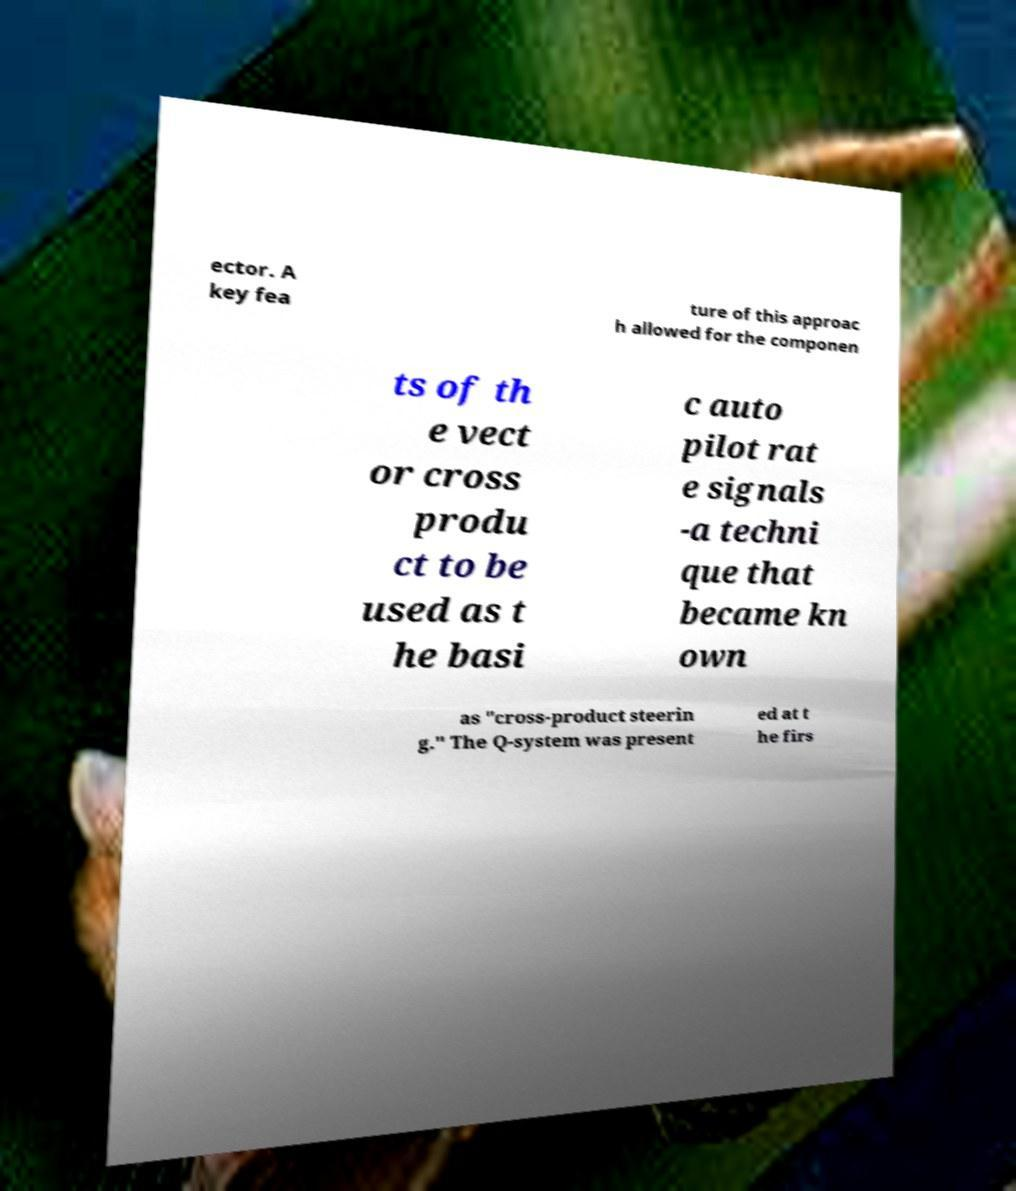Can you read and provide the text displayed in the image?This photo seems to have some interesting text. Can you extract and type it out for me? ector. A key fea ture of this approac h allowed for the componen ts of th e vect or cross produ ct to be used as t he basi c auto pilot rat e signals -a techni que that became kn own as "cross-product steerin g." The Q-system was present ed at t he firs 